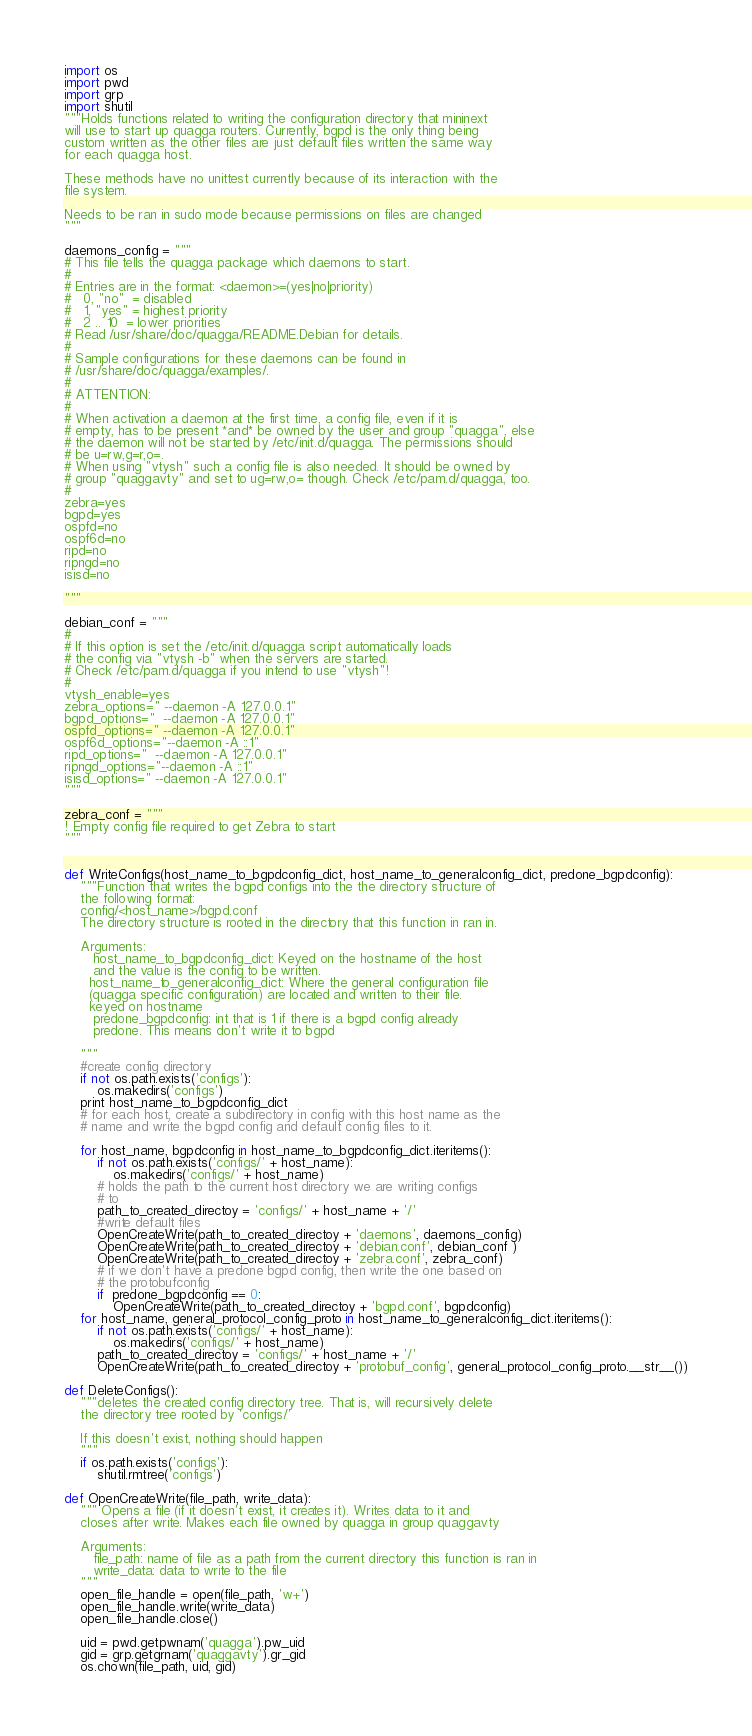Convert code to text. <code><loc_0><loc_0><loc_500><loc_500><_Python_>import os
import pwd
import grp
import shutil
"""Holds functions related to writing the configuration directory that mininext
will use to start up quagga routers. Currently, bgpd is the only thing being
custom written as the other files are just default files written the same way
for each quagga host.

These methods have no unittest currently because of its interaction with the
file system.

Needs to be ran in sudo mode because permissions on files are changed
"""

daemons_config = """
# This file tells the quagga package which daemons to start.
#
# Entries are in the format: <daemon>=(yes|no|priority)
#   0, "no"  = disabled
#   1, "yes" = highest priority
#   2 .. 10  = lower priorities
# Read /usr/share/doc/quagga/README.Debian for details.
#
# Sample configurations for these daemons can be found in
# /usr/share/doc/quagga/examples/.
#
# ATTENTION: 
#
# When activation a daemon at the first time, a config file, even if it is
# empty, has to be present *and* be owned by the user and group "quagga", else
# the daemon will not be started by /etc/init.d/quagga. The permissions should
# be u=rw,g=r,o=.
# When using "vtysh" such a config file is also needed. It should be owned by
# group "quaggavty" and set to ug=rw,o= though. Check /etc/pam.d/quagga, too.
#
zebra=yes
bgpd=yes
ospfd=no
ospf6d=no
ripd=no
ripngd=no
isisd=no

"""

debian_conf = """
#
# If this option is set the /etc/init.d/quagga script automatically loads
# the config via "vtysh -b" when the servers are started. 
# Check /etc/pam.d/quagga if you intend to use "vtysh"!
#
vtysh_enable=yes
zebra_options=" --daemon -A 127.0.0.1"
bgpd_options="  --daemon -A 127.0.0.1"
ospfd_options=" --daemon -A 127.0.0.1"
ospf6d_options="--daemon -A ::1"
ripd_options="  --daemon -A 127.0.0.1"
ripngd_options="--daemon -A ::1"
isisd_options=" --daemon -A 127.0.0.1"
"""

zebra_conf = """
! Empty config file required to get Zebra to start
"""


def WriteConfigs(host_name_to_bgpdconfig_dict, host_name_to_generalconfig_dict, predone_bgpdconfig):
    """Function that writes the bgpd configs into the the directory structure of
    the following format:
    config/<host_name>/bgpd.conf
    The directory structure is rooted in the directory that this function in ran in.

    Arguments:
       host_name_to_bgpdconfig_dict: Keyed on the hostname of the host
       and the value is the config to be written.
      host_name_to_generalconfig_dict: Where the general configuration file
      (quagga specific configuration) are located and written to their file.
      keyed on hostname
       predone_bgpdconfig: int that is 1 if there is a bgpd config already
       predone. This means don't write it to bgpd

    """
    #create config directory
    if not os.path.exists('configs'):
        os.makedirs('configs')
    print host_name_to_bgpdconfig_dict
    # for each host, create a subdirectory in config with this host name as the
    # name and write the bgpd config and default config files to it.

    for host_name, bgpdconfig in host_name_to_bgpdconfig_dict.iteritems():
        if not os.path.exists('configs/' + host_name):
            os.makedirs('configs/' + host_name)
        # holds the path to the current host directory we are writing configs
        # to
        path_to_created_directoy = 'configs/' + host_name + '/'
        #write default files
        OpenCreateWrite(path_to_created_directoy + 'daemons', daemons_config)
        OpenCreateWrite(path_to_created_directoy + 'debian.conf', debian_conf )
        OpenCreateWrite(path_to_created_directoy + 'zebra.conf', zebra_conf)
        # if we don't have a predone bgpd config, then write the one based on
        # the protobufconfig
        if  predone_bgpdconfig == 0:
            OpenCreateWrite(path_to_created_directoy + 'bgpd.conf', bgpdconfig)
    for host_name, general_protocol_config_proto in host_name_to_generalconfig_dict.iteritems():
        if not os.path.exists('configs/' + host_name):
            os.makedirs('configs/' + host_name)
        path_to_created_directoy = 'configs/' + host_name + '/'
        OpenCreateWrite(path_to_created_directoy + 'protobuf_config', general_protocol_config_proto.__str__())

def DeleteConfigs():
    """deletes the created config directory tree. That is, will recursively delete
    the directory tree rooted by 'configs/'

    If this doesn't exist, nothing should happen
    """
    if os.path.exists('configs'):
        shutil.rmtree('configs')

def OpenCreateWrite(file_path, write_data):
    """ Opens a file (if it doesn't exist, it creates it). Writes data to it and
    closes after write. Makes each file owned by quagga in group quaggavty

    Arguments:
       file_path: name of file as a path from the current directory this function is ran in
       write_data: data to write to the file
    """
    open_file_handle = open(file_path, 'w+')
    open_file_handle.write(write_data)
    open_file_handle.close()

    uid = pwd.getpwnam('quagga').pw_uid
    gid = grp.getgrnam('quaggavty').gr_gid
    os.chown(file_path, uid, gid)

</code> 